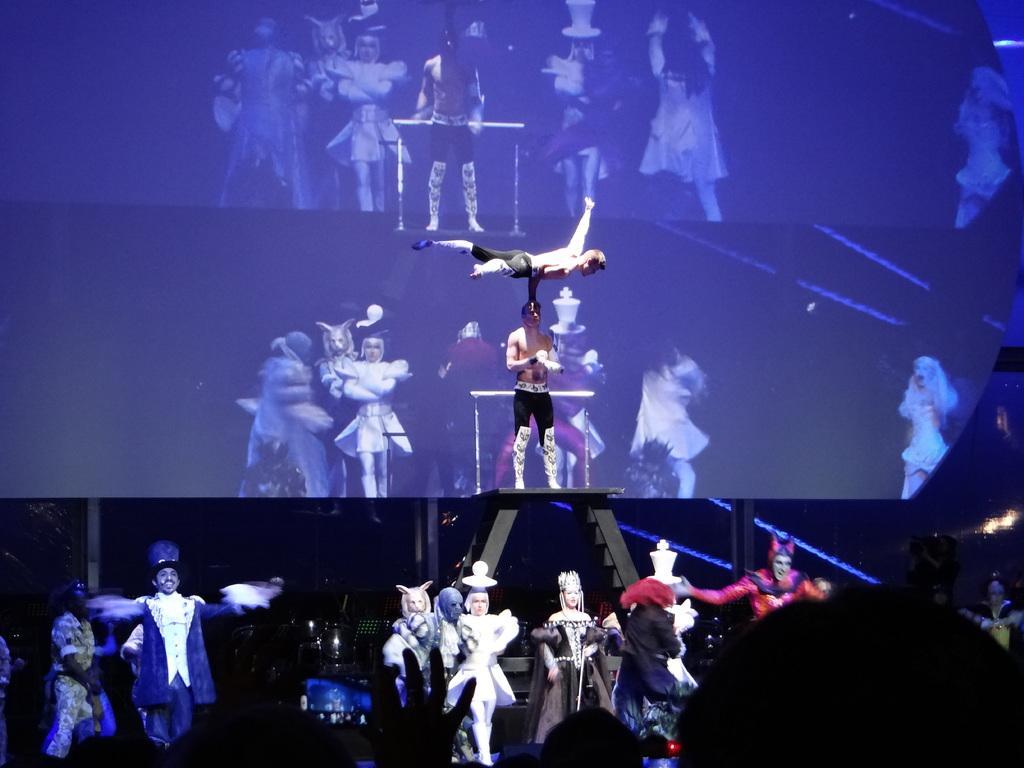Can you describe this image briefly? In this picture we can observe some people on the stage. There are men and women in different costumes. They were performing an activity. In the background we can observe a big screen. 